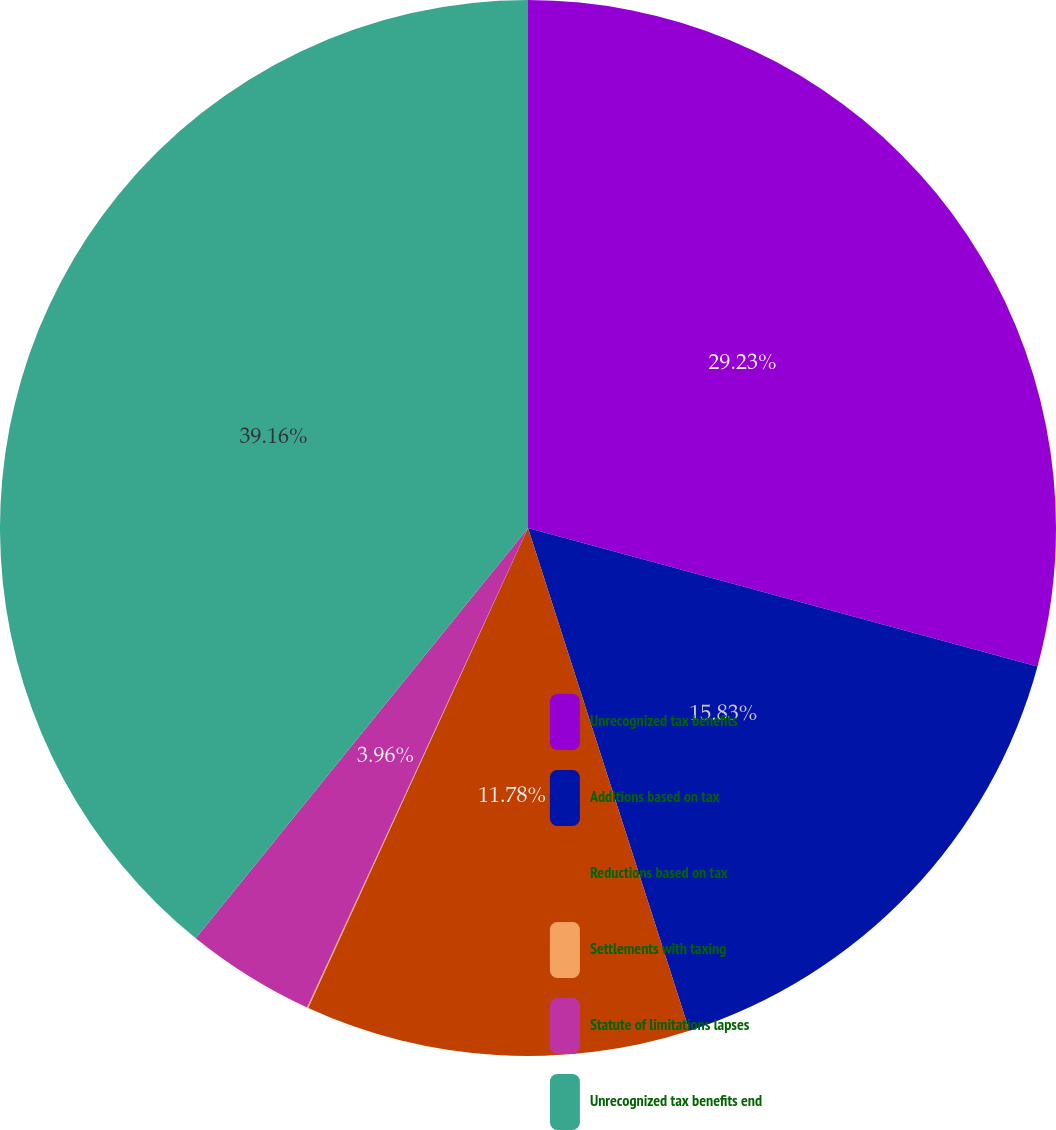Convert chart to OTSL. <chart><loc_0><loc_0><loc_500><loc_500><pie_chart><fcel>Unrecognized tax benefits<fcel>Additions based on tax<fcel>Reductions based on tax<fcel>Settlements with taxing<fcel>Statute of limitations lapses<fcel>Unrecognized tax benefits end<nl><fcel>29.23%<fcel>15.83%<fcel>11.78%<fcel>0.04%<fcel>3.96%<fcel>39.17%<nl></chart> 